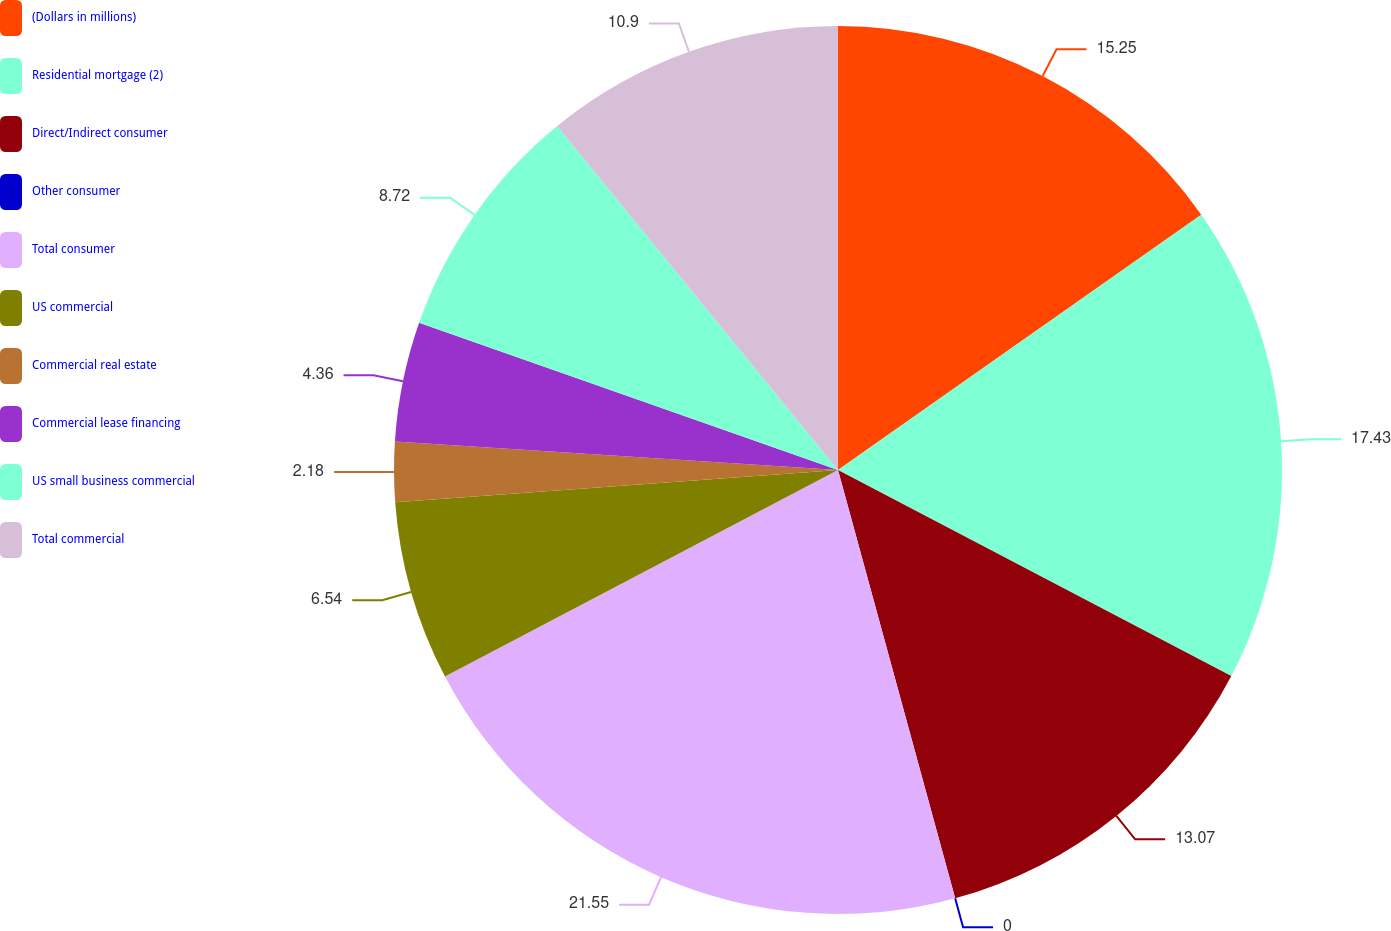Convert chart to OTSL. <chart><loc_0><loc_0><loc_500><loc_500><pie_chart><fcel>(Dollars in millions)<fcel>Residential mortgage (2)<fcel>Direct/Indirect consumer<fcel>Other consumer<fcel>Total consumer<fcel>US commercial<fcel>Commercial real estate<fcel>Commercial lease financing<fcel>US small business commercial<fcel>Total commercial<nl><fcel>15.25%<fcel>17.43%<fcel>13.07%<fcel>0.0%<fcel>21.55%<fcel>6.54%<fcel>2.18%<fcel>4.36%<fcel>8.72%<fcel>10.9%<nl></chart> 